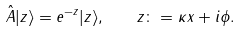Convert formula to latex. <formula><loc_0><loc_0><loc_500><loc_500>\hat { A } | z \rangle = e ^ { - z } | z \rangle , \quad z \colon = \kappa x + i \phi .</formula> 